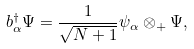Convert formula to latex. <formula><loc_0><loc_0><loc_500><loc_500>b _ { \alpha } ^ { \dagger } \Psi = { \frac { 1 } { \sqrt { N + 1 } } } \psi _ { \alpha } \otimes _ { + } \Psi ,</formula> 